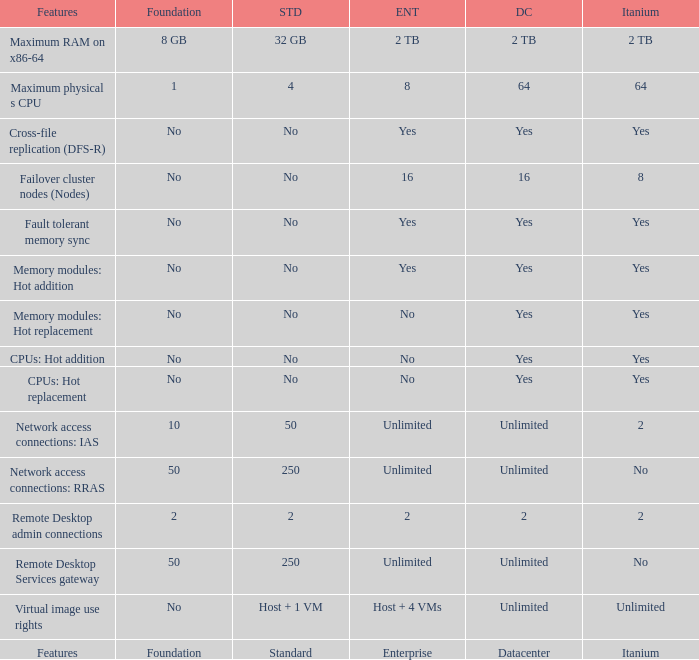Which Features have Yes listed under Datacenter? Cross-file replication (DFS-R), Fault tolerant memory sync, Memory modules: Hot addition, Memory modules: Hot replacement, CPUs: Hot addition, CPUs: Hot replacement. Help me parse the entirety of this table. {'header': ['Features', 'Foundation', 'STD', 'ENT', 'DC', 'Itanium'], 'rows': [['Maximum RAM on x86-64', '8 GB', '32 GB', '2 TB', '2 TB', '2 TB'], ['Maximum physical s CPU', '1', '4', '8', '64', '64'], ['Cross-file replication (DFS-R)', 'No', 'No', 'Yes', 'Yes', 'Yes'], ['Failover cluster nodes (Nodes)', 'No', 'No', '16', '16', '8'], ['Fault tolerant memory sync', 'No', 'No', 'Yes', 'Yes', 'Yes'], ['Memory modules: Hot addition', 'No', 'No', 'Yes', 'Yes', 'Yes'], ['Memory modules: Hot replacement', 'No', 'No', 'No', 'Yes', 'Yes'], ['CPUs: Hot addition', 'No', 'No', 'No', 'Yes', 'Yes'], ['CPUs: Hot replacement', 'No', 'No', 'No', 'Yes', 'Yes'], ['Network access connections: IAS', '10', '50', 'Unlimited', 'Unlimited', '2'], ['Network access connections: RRAS', '50', '250', 'Unlimited', 'Unlimited', 'No'], ['Remote Desktop admin connections', '2', '2', '2', '2', '2'], ['Remote Desktop Services gateway', '50', '250', 'Unlimited', 'Unlimited', 'No'], ['Virtual image use rights', 'No', 'Host + 1 VM', 'Host + 4 VMs', 'Unlimited', 'Unlimited'], ['Features', 'Foundation', 'Standard', 'Enterprise', 'Datacenter', 'Itanium']]} 